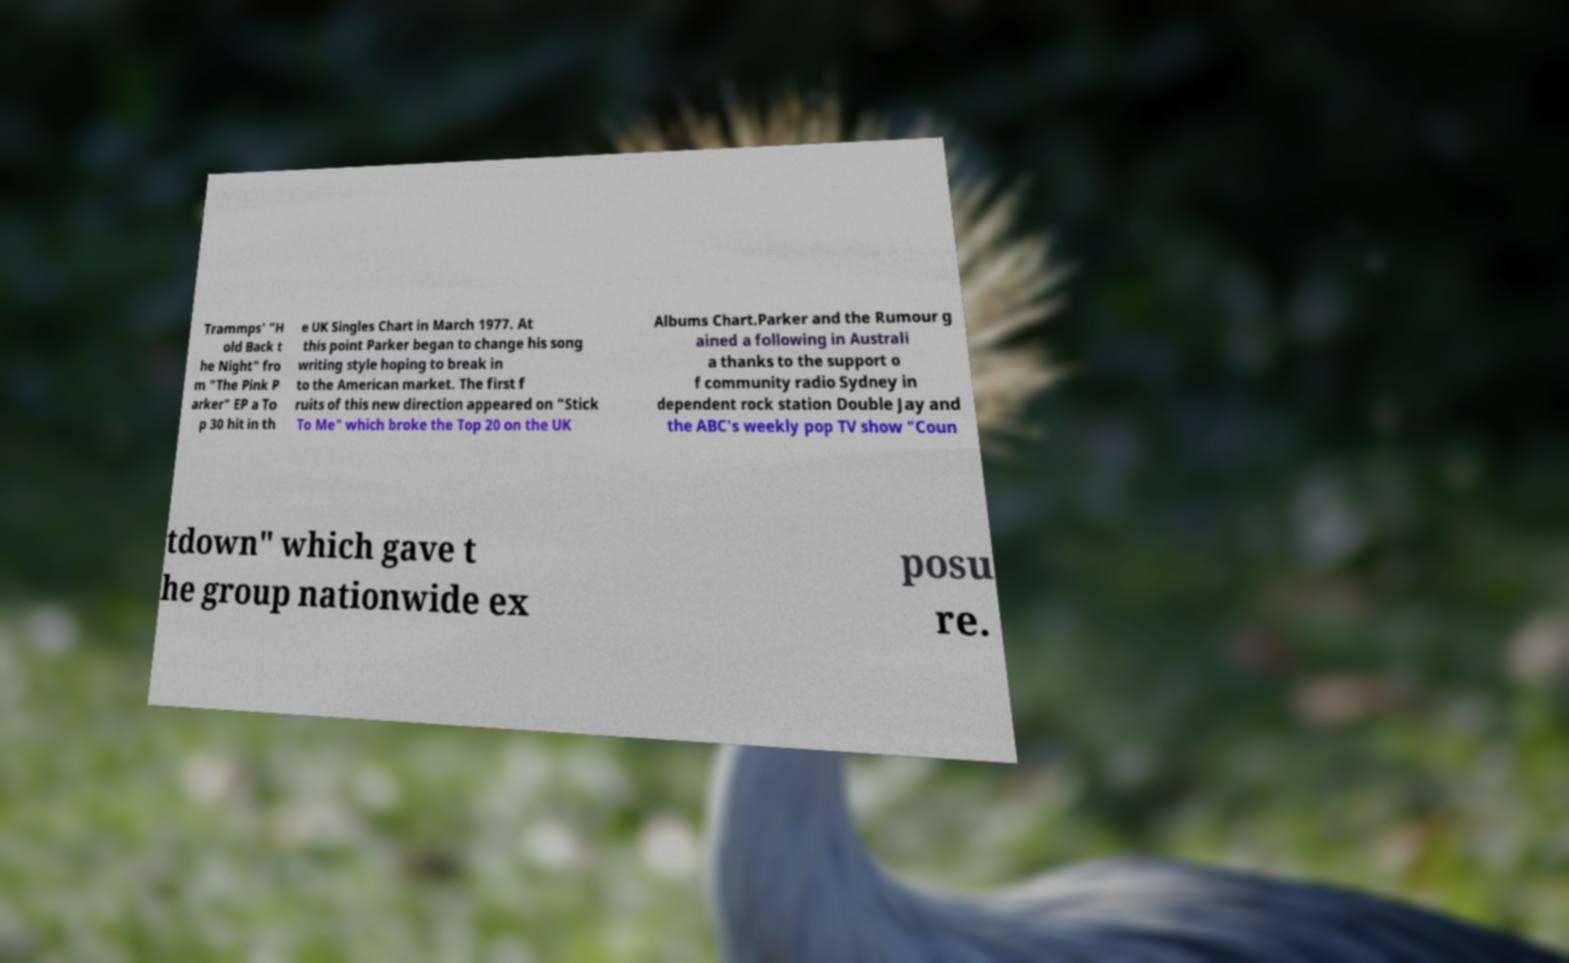Could you extract and type out the text from this image? Trammps' "H old Back t he Night" fro m "The Pink P arker" EP a To p 30 hit in th e UK Singles Chart in March 1977. At this point Parker began to change his song writing style hoping to break in to the American market. The first f ruits of this new direction appeared on "Stick To Me" which broke the Top 20 on the UK Albums Chart.Parker and the Rumour g ained a following in Australi a thanks to the support o f community radio Sydney in dependent rock station Double Jay and the ABC's weekly pop TV show "Coun tdown" which gave t he group nationwide ex posu re. 